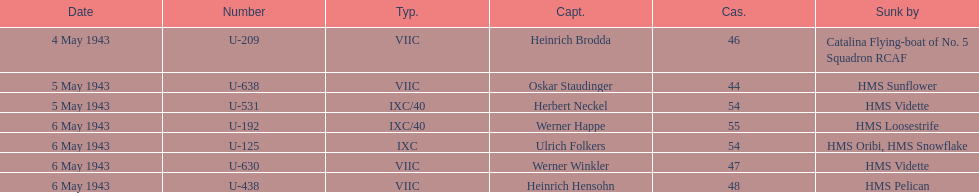How many captains are listed? 7. Could you parse the entire table as a dict? {'header': ['Date', 'Number', 'Typ.', 'Capt.', 'Cas.', 'Sunk by'], 'rows': [['4 May 1943', 'U-209', 'VIIC', 'Heinrich Brodda', '46', 'Catalina Flying-boat of No. 5 Squadron RCAF'], ['5 May 1943', 'U-638', 'VIIC', 'Oskar Staudinger', '44', 'HMS Sunflower'], ['5 May 1943', 'U-531', 'IXC/40', 'Herbert Neckel', '54', 'HMS Vidette'], ['6 May 1943', 'U-192', 'IXC/40', 'Werner Happe', '55', 'HMS Loosestrife'], ['6 May 1943', 'U-125', 'IXC', 'Ulrich Folkers', '54', 'HMS Oribi, HMS Snowflake'], ['6 May 1943', 'U-630', 'VIIC', 'Werner Winkler', '47', 'HMS Vidette'], ['6 May 1943', 'U-438', 'VIIC', 'Heinrich Hensohn', '48', 'HMS Pelican']]} 